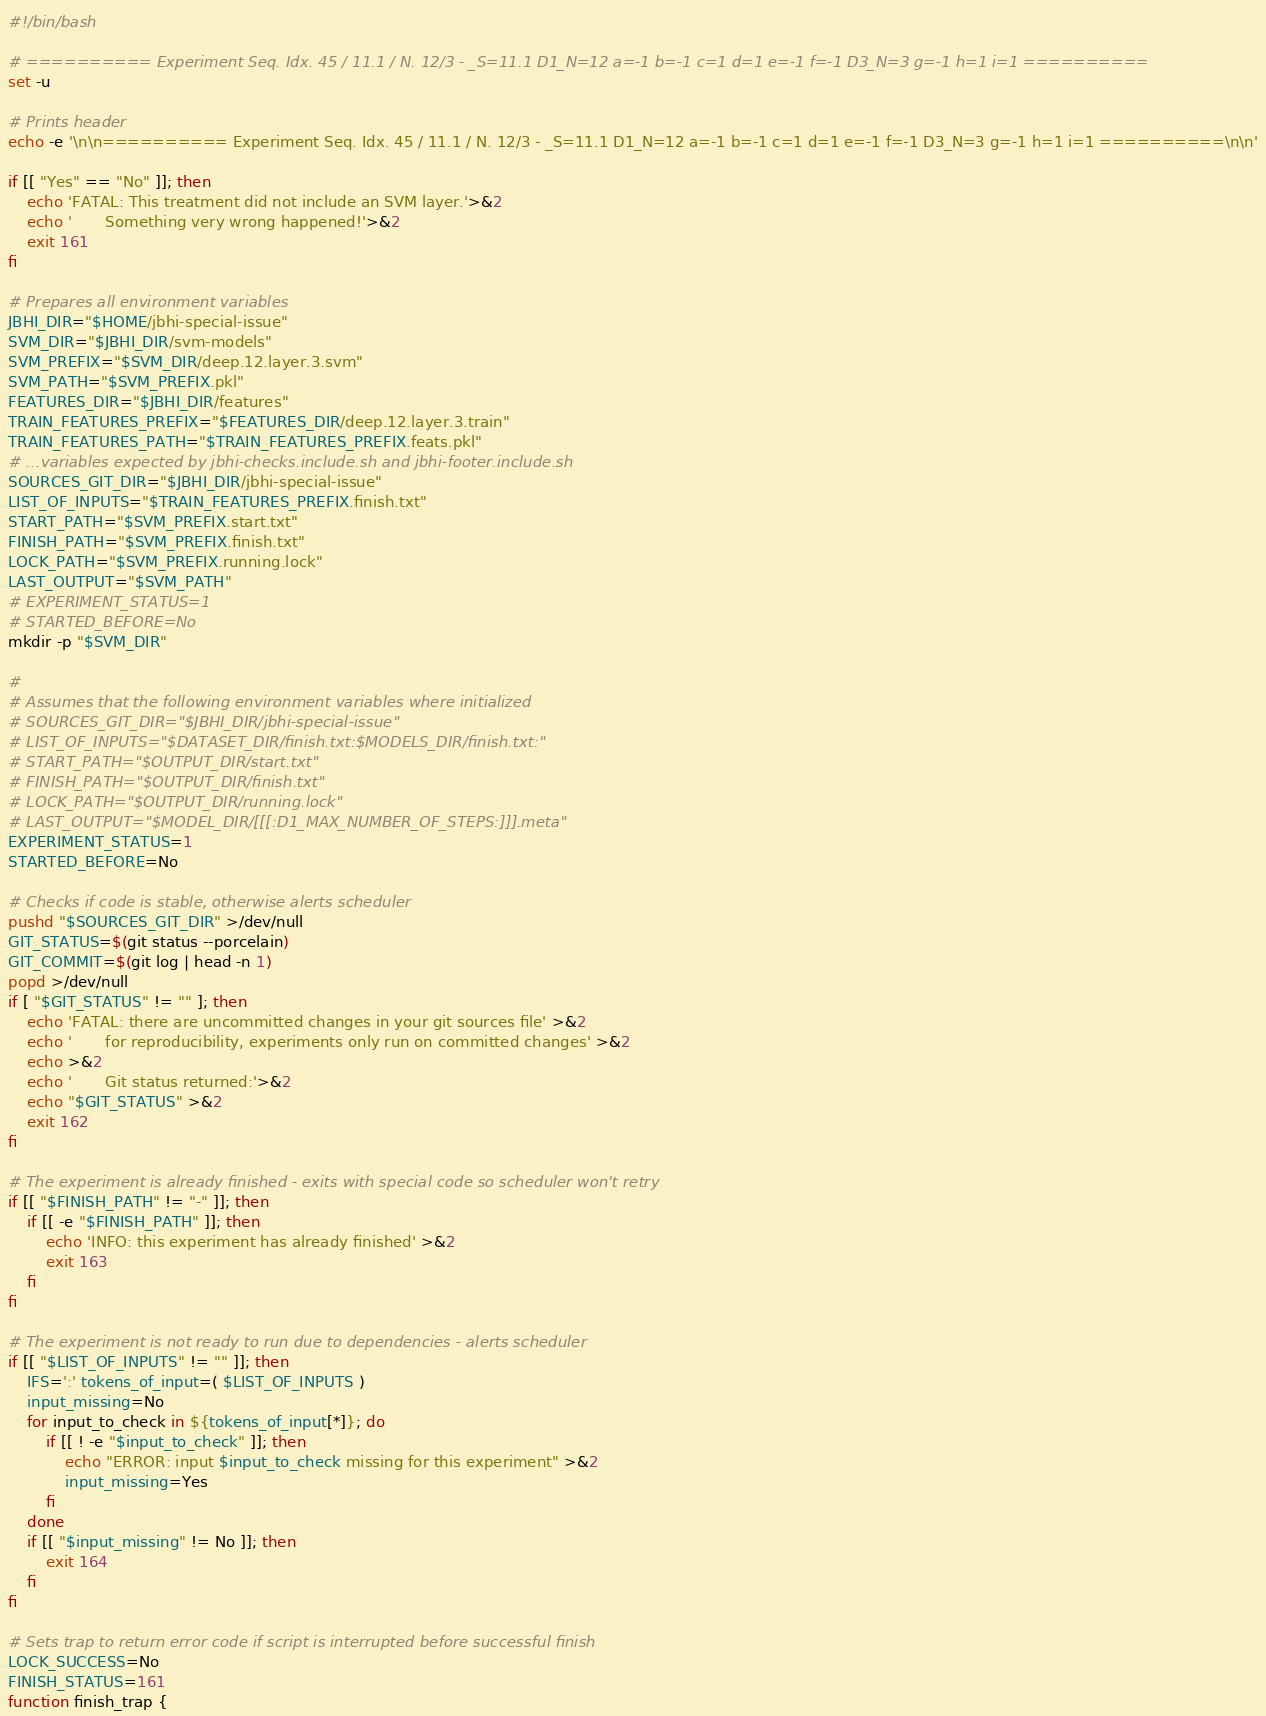<code> <loc_0><loc_0><loc_500><loc_500><_Bash_>#!/bin/bash

# ========== Experiment Seq. Idx. 45 / 11.1 / N. 12/3 - _S=11.1 D1_N=12 a=-1 b=-1 c=1 d=1 e=-1 f=-1 D3_N=3 g=-1 h=1 i=1 ==========
set -u

# Prints header
echo -e '\n\n========== Experiment Seq. Idx. 45 / 11.1 / N. 12/3 - _S=11.1 D1_N=12 a=-1 b=-1 c=1 d=1 e=-1 f=-1 D3_N=3 g=-1 h=1 i=1 ==========\n\n'

if [[ "Yes" == "No" ]]; then
    echo 'FATAL: This treatment did not include an SVM layer.'>&2
    echo '       Something very wrong happened!'>&2
    exit 161
fi

# Prepares all environment variables
JBHI_DIR="$HOME/jbhi-special-issue"
SVM_DIR="$JBHI_DIR/svm-models"
SVM_PREFIX="$SVM_DIR/deep.12.layer.3.svm"
SVM_PATH="$SVM_PREFIX.pkl"
FEATURES_DIR="$JBHI_DIR/features"
TRAIN_FEATURES_PREFIX="$FEATURES_DIR/deep.12.layer.3.train"
TRAIN_FEATURES_PATH="$TRAIN_FEATURES_PREFIX.feats.pkl"
# ...variables expected by jbhi-checks.include.sh and jbhi-footer.include.sh
SOURCES_GIT_DIR="$JBHI_DIR/jbhi-special-issue"
LIST_OF_INPUTS="$TRAIN_FEATURES_PREFIX.finish.txt"
START_PATH="$SVM_PREFIX.start.txt"
FINISH_PATH="$SVM_PREFIX.finish.txt"
LOCK_PATH="$SVM_PREFIX.running.lock"
LAST_OUTPUT="$SVM_PATH"
# EXPERIMENT_STATUS=1
# STARTED_BEFORE=No
mkdir -p "$SVM_DIR"

#
# Assumes that the following environment variables where initialized
# SOURCES_GIT_DIR="$JBHI_DIR/jbhi-special-issue"
# LIST_OF_INPUTS="$DATASET_DIR/finish.txt:$MODELS_DIR/finish.txt:"
# START_PATH="$OUTPUT_DIR/start.txt"
# FINISH_PATH="$OUTPUT_DIR/finish.txt"
# LOCK_PATH="$OUTPUT_DIR/running.lock"
# LAST_OUTPUT="$MODEL_DIR/[[[:D1_MAX_NUMBER_OF_STEPS:]]].meta"
EXPERIMENT_STATUS=1
STARTED_BEFORE=No

# Checks if code is stable, otherwise alerts scheduler
pushd "$SOURCES_GIT_DIR" >/dev/null
GIT_STATUS=$(git status --porcelain)
GIT_COMMIT=$(git log | head -n 1)
popd >/dev/null
if [ "$GIT_STATUS" != "" ]; then
    echo 'FATAL: there are uncommitted changes in your git sources file' >&2
    echo '       for reproducibility, experiments only run on committed changes' >&2
    echo >&2
    echo '       Git status returned:'>&2
    echo "$GIT_STATUS" >&2
    exit 162
fi

# The experiment is already finished - exits with special code so scheduler won't retry
if [[ "$FINISH_PATH" != "-" ]]; then
    if [[ -e "$FINISH_PATH" ]]; then
        echo 'INFO: this experiment has already finished' >&2
        exit 163
    fi
fi

# The experiment is not ready to run due to dependencies - alerts scheduler
if [[ "$LIST_OF_INPUTS" != "" ]]; then
    IFS=':' tokens_of_input=( $LIST_OF_INPUTS )
    input_missing=No
    for input_to_check in ${tokens_of_input[*]}; do
        if [[ ! -e "$input_to_check" ]]; then
            echo "ERROR: input $input_to_check missing for this experiment" >&2
            input_missing=Yes
        fi
    done
    if [[ "$input_missing" != No ]]; then
        exit 164
    fi
fi

# Sets trap to return error code if script is interrupted before successful finish
LOCK_SUCCESS=No
FINISH_STATUS=161
function finish_trap {</code> 